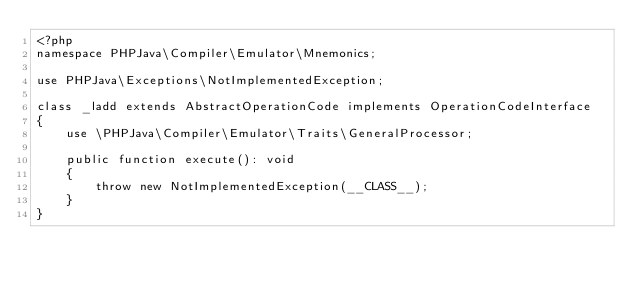Convert code to text. <code><loc_0><loc_0><loc_500><loc_500><_PHP_><?php
namespace PHPJava\Compiler\Emulator\Mnemonics;

use PHPJava\Exceptions\NotImplementedException;

class _ladd extends AbstractOperationCode implements OperationCodeInterface
{
    use \PHPJava\Compiler\Emulator\Traits\GeneralProcessor;

    public function execute(): void
    {
        throw new NotImplementedException(__CLASS__);
    }
}
</code> 